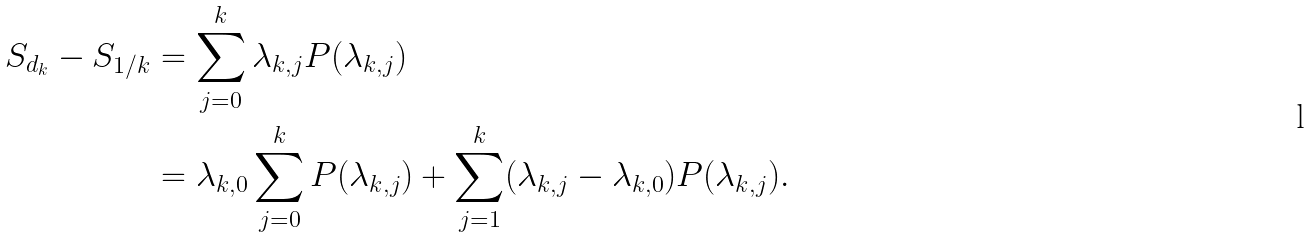<formula> <loc_0><loc_0><loc_500><loc_500>S _ { d _ { k } } - S _ { 1 / k } & = \sum _ { j = 0 } ^ { k } \lambda _ { k , j } P ( \lambda _ { k , j } ) \\ & = \lambda _ { k , 0 } \sum _ { j = 0 } ^ { k } P ( \lambda _ { k , j } ) + \sum _ { j = 1 } ^ { k } ( \lambda _ { k , j } - \lambda _ { k , 0 } ) P ( \lambda _ { k , j } ) .</formula> 